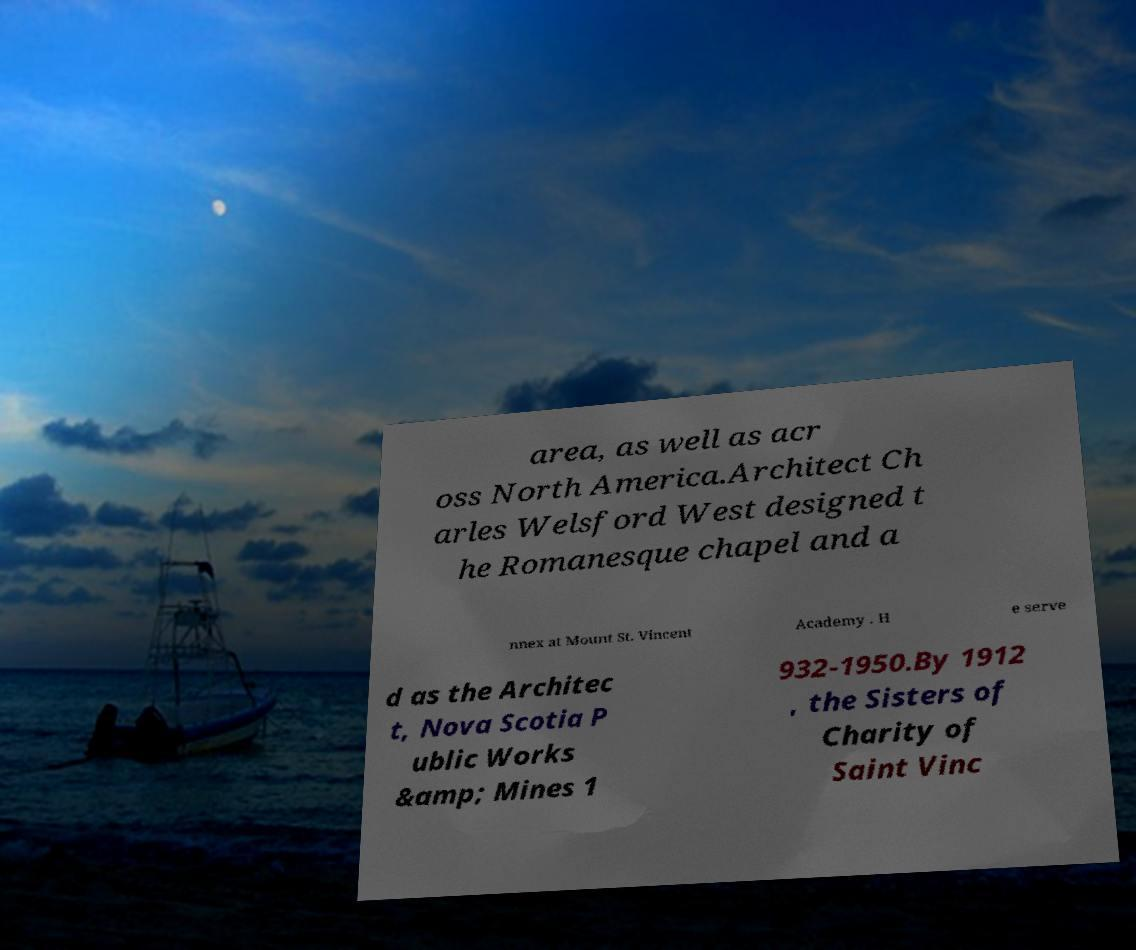Please identify and transcribe the text found in this image. area, as well as acr oss North America.Architect Ch arles Welsford West designed t he Romanesque chapel and a nnex at Mount St. Vincent Academy . H e serve d as the Architec t, Nova Scotia P ublic Works &amp; Mines 1 932-1950.By 1912 , the Sisters of Charity of Saint Vinc 